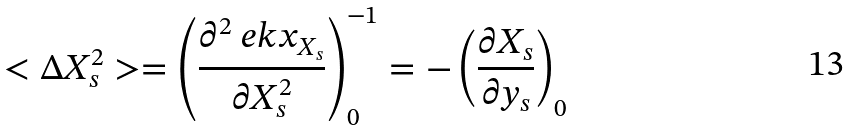<formula> <loc_0><loc_0><loc_500><loc_500>< \Delta X _ { s } ^ { 2 } > = \left ( \frac { \partial ^ { 2 } \ e k x _ { X _ { s } } } { \partial X _ { s } ^ { 2 } } \right ) _ { 0 } ^ { - 1 } = - \left ( \frac { \partial X _ { s } } { \partial y _ { s } } \right ) _ { 0 }</formula> 